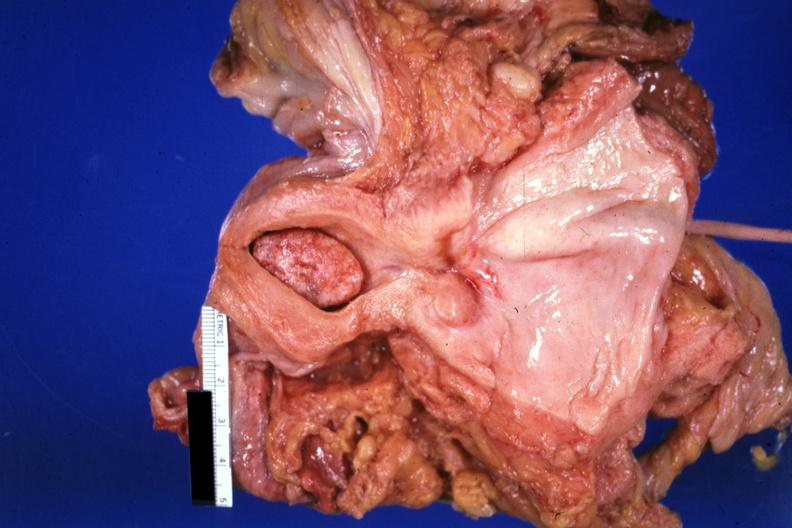what is present?
Answer the question using a single word or phrase. Uterus 